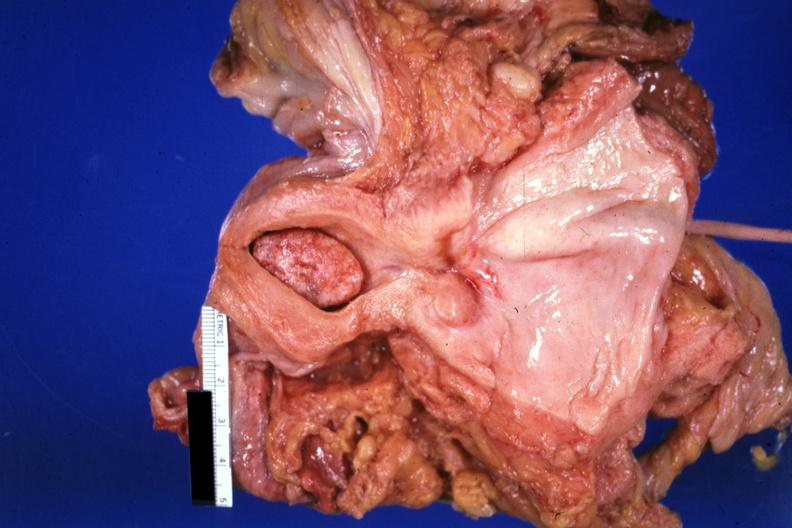what is present?
Answer the question using a single word or phrase. Uterus 